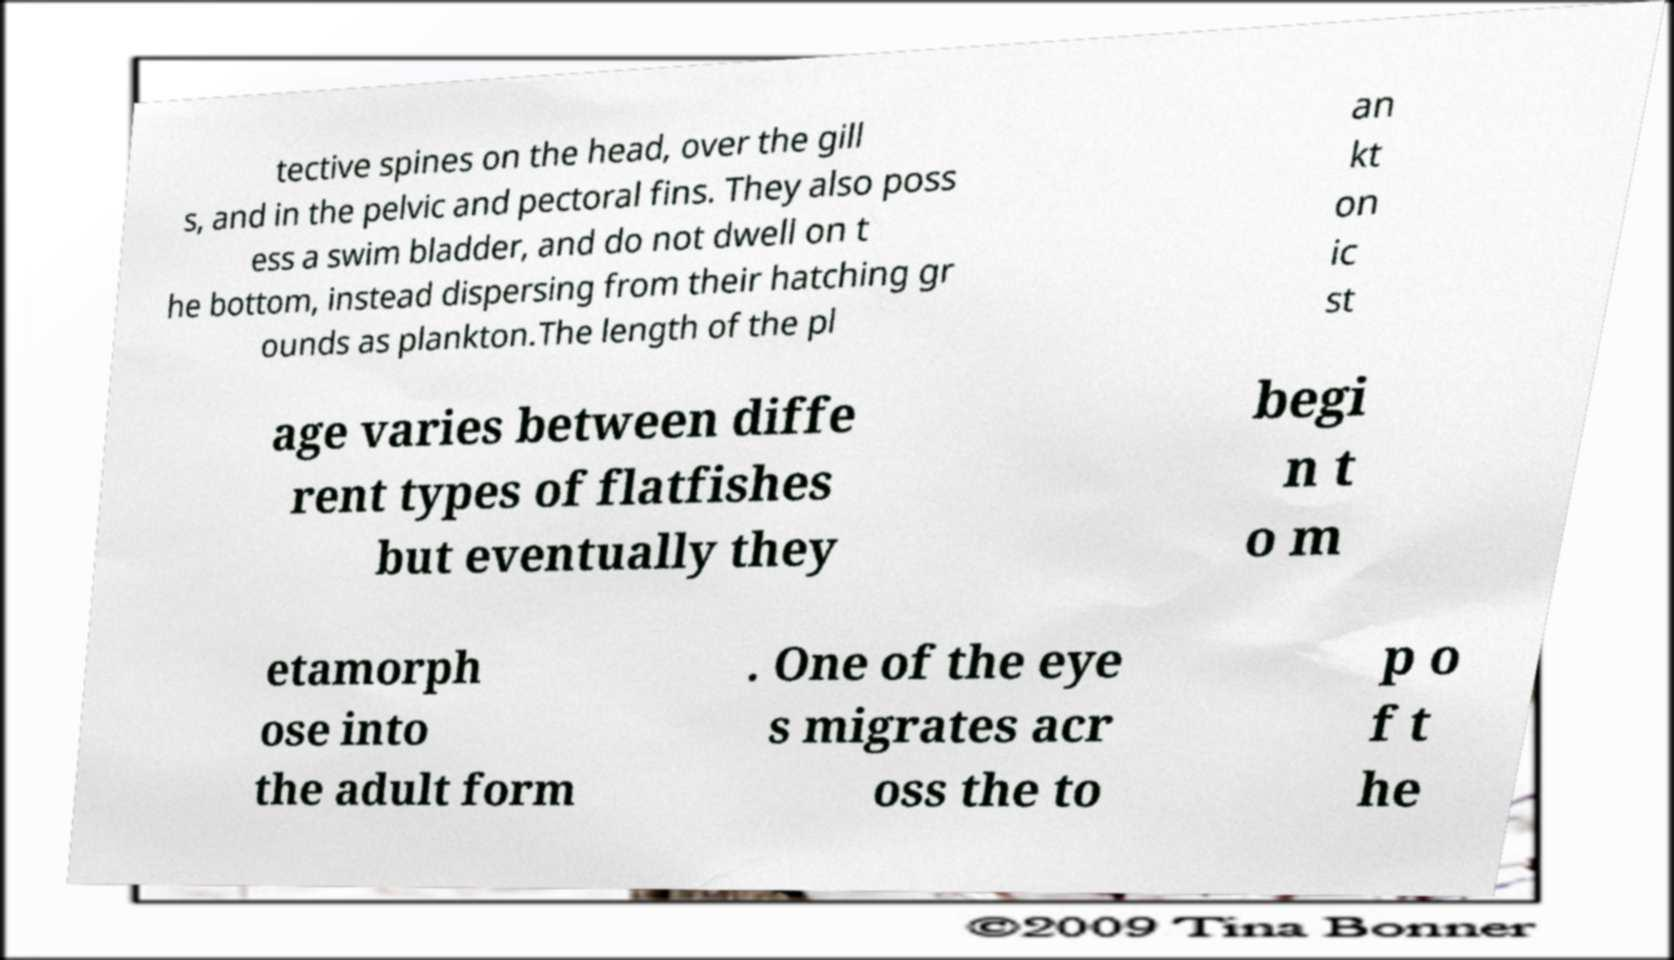I need the written content from this picture converted into text. Can you do that? tective spines on the head, over the gill s, and in the pelvic and pectoral fins. They also poss ess a swim bladder, and do not dwell on t he bottom, instead dispersing from their hatching gr ounds as plankton.The length of the pl an kt on ic st age varies between diffe rent types of flatfishes but eventually they begi n t o m etamorph ose into the adult form . One of the eye s migrates acr oss the to p o f t he 